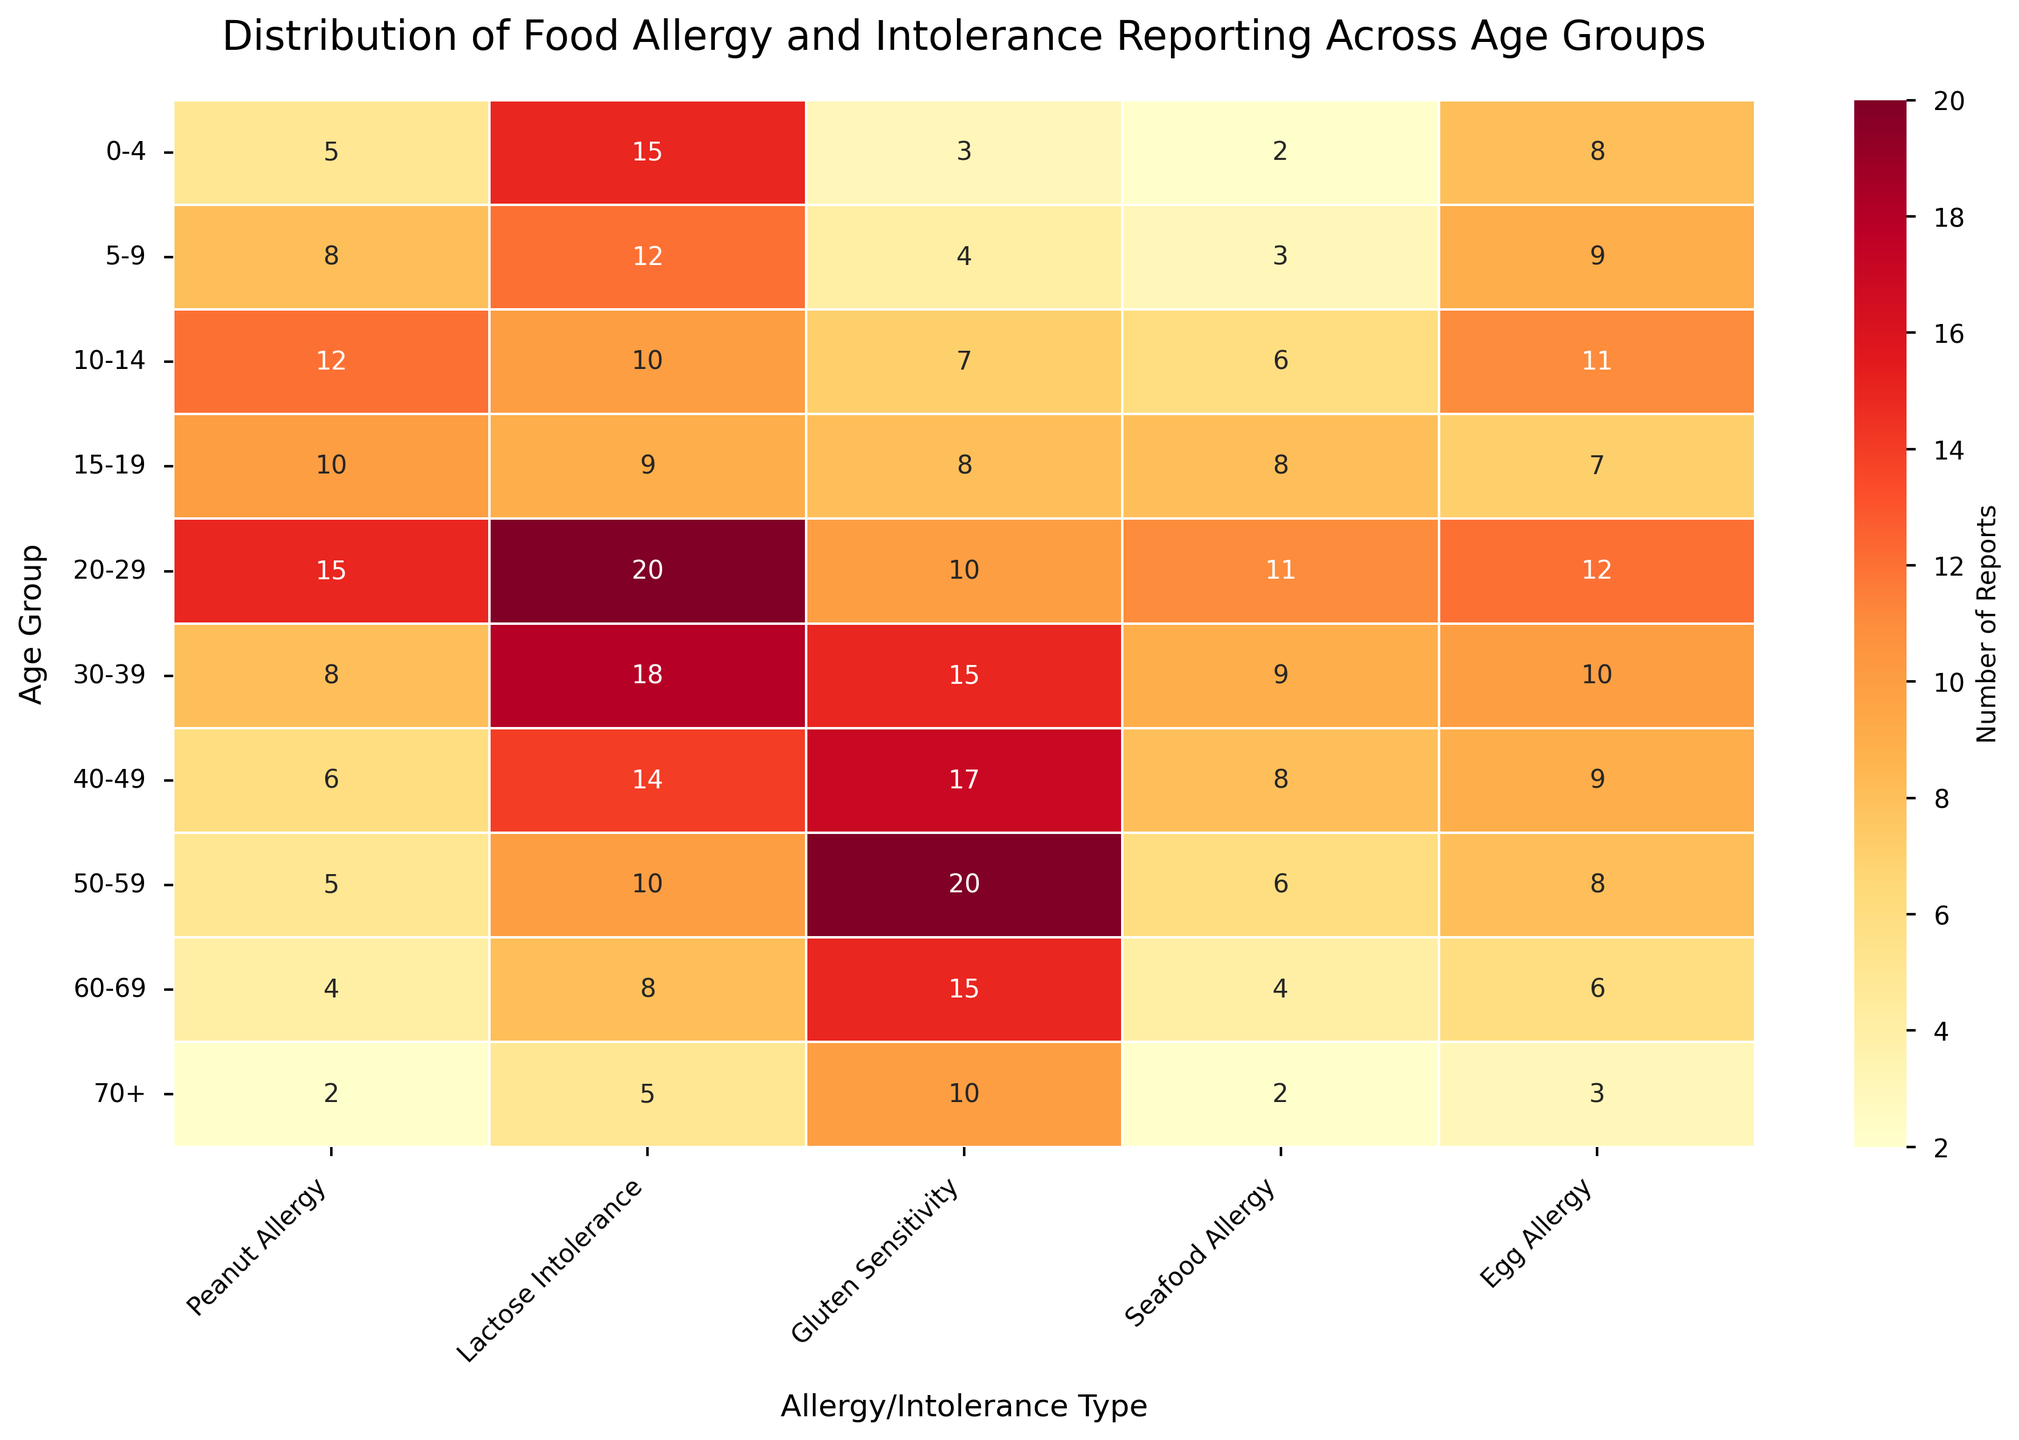What is the title of the heatmap? The title of the heatmap is displayed at the top of the plot.
Answer: Distribution of Food Allergy and Intolerance Reporting Across Age Groups Which age group reports the highest number of lactose intolerance cases? Look at the column labeled 'Lactose Intolerance' and find the highest value. Identify the age group corresponding to this value.
Answer: 20-29 What is the total number of peanut allergy reports for children age 0-14? Sum the values in the 'Peanut Allergy' column for the age groups 0-4, 5-9, and 10-14 (5 + 8 + 12).
Answer: 25 Which age group has more reports of gluten sensitivity: 30-39 or 40-49? Compare the values in the 'Gluten Sensitivity' column for age groups 30-39 and 40-49 (15 and 17).
Answer: 40-49 How does the number of seafood allergy reports change from age group 15-19 to 20-29? Look at the values in the 'Seafood Allergy' column for age groups 15-19 and 20-29 (8 and 11). Subtract the former value from the latter.
Answer: It increases by 3 What is the average number of egg allergy reports across all age groups? Sum the values in the 'Egg Allergy' column and divide by the number of age groups (8+9+11+7+12+10+9+8+6+3) / 10.
Answer: 8.3 Which has fewer reports: gluten sensitivity in the 0-4 age group or peanut allergy in the 60-69 age group? Compare the values in 'Gluten Sensitivity' for the 0-4 age group and 'Peanut Allergy' for the 60-69 age group (3 and 4).
Answer: Gluten sensitivity in 0-4 Is there any age group where seafood allergy reports are higher than gluten sensitivity reports? Compare the values in the 'Seafood Allergy' column with those in the 'Gluten Sensitivity' column for each age group.
Answer: No, there isn't What is the range of lactose intolerance reports across all age groups? Identify the minimum and maximum values in the 'Lactose Intolerance' column (5 and 20) and subtract the minimum from the maximum.
Answer: 15 At what age group does the number of peanut allergy reports start to decline significantly? Track the values in the 'Peanut Allergy' column from the top down and note the age group where a noticeable decline starts (from 20-29 to 30-39 where the value drops from 15 to 8).
Answer: 30-39 